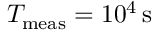Convert formula to latex. <formula><loc_0><loc_0><loc_500><loc_500>T _ { m e a s } = 1 0 ^ { 4 } \, s</formula> 